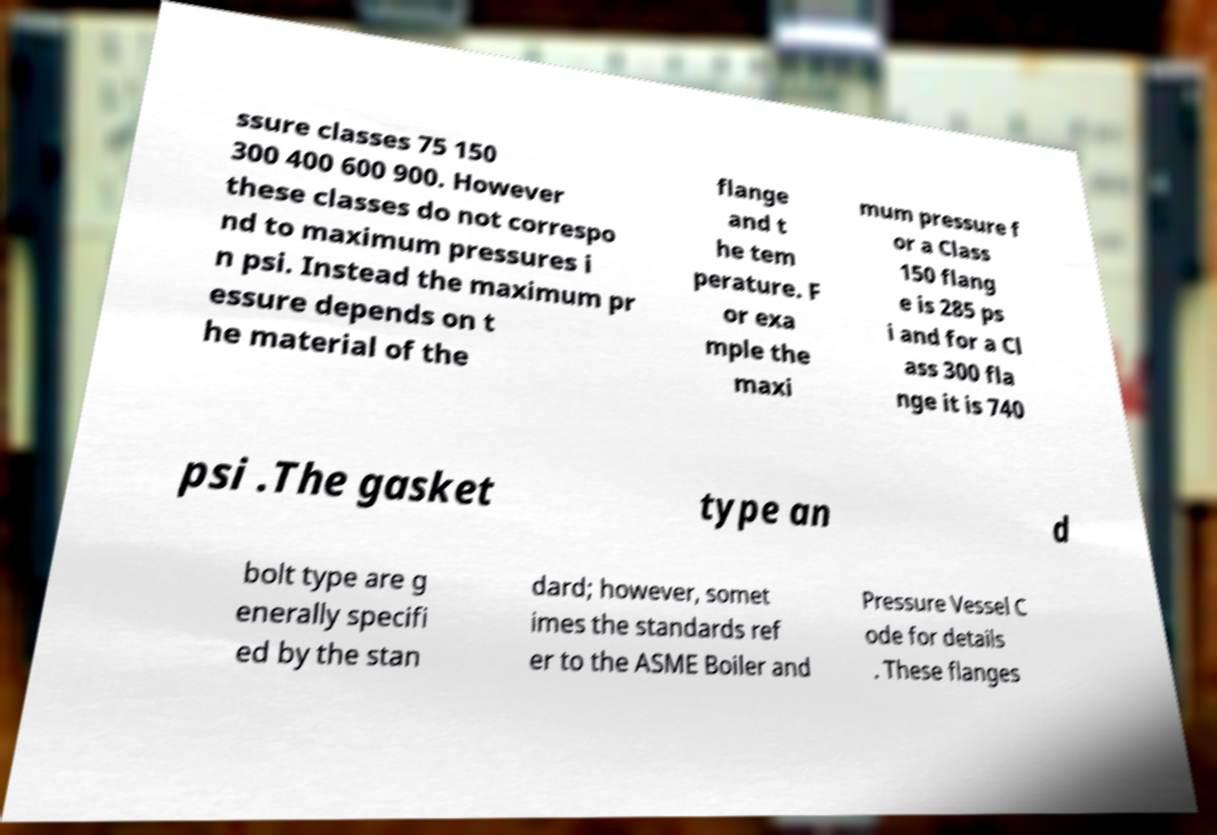Can you accurately transcribe the text from the provided image for me? ssure classes 75 150 300 400 600 900. However these classes do not correspo nd to maximum pressures i n psi. Instead the maximum pr essure depends on t he material of the flange and t he tem perature. F or exa mple the maxi mum pressure f or a Class 150 flang e is 285 ps i and for a Cl ass 300 fla nge it is 740 psi .The gasket type an d bolt type are g enerally specifi ed by the stan dard; however, somet imes the standards ref er to the ASME Boiler and Pressure Vessel C ode for details . These flanges 